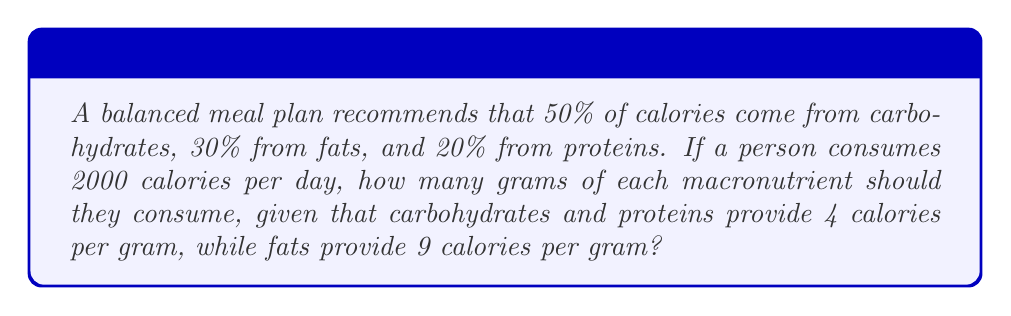Show me your answer to this math problem. Let's approach this step-by-step:

1. Calculate the calories from each macronutrient:
   Carbohydrates: $50\% \text{ of } 2000 = 0.50 \times 2000 = 1000$ calories
   Fats: $30\% \text{ of } 2000 = 0.30 \times 2000 = 600$ calories
   Proteins: $20\% \text{ of } 2000 = 0.20 \times 2000 = 400$ calories

2. Convert calories to grams for each macronutrient:

   For carbohydrates:
   $$\text{Grams of carbohydrates} = \frac{1000 \text{ calories}}{4 \text{ calories/gram}} = 250 \text{ grams}$$

   For fats:
   $$\text{Grams of fats} = \frac{600 \text{ calories}}{9 \text{ calories/gram}} \approx 66.67 \text{ grams}$$

   For proteins:
   $$\text{Grams of proteins} = \frac{400 \text{ calories}}{4 \text{ calories/gram}} = 100 \text{ grams}$$

3. Round the results to the nearest whole number for practical meal planning.
Answer: Carbohydrates: 250 grams
Fats: 67 grams
Proteins: 100 grams 